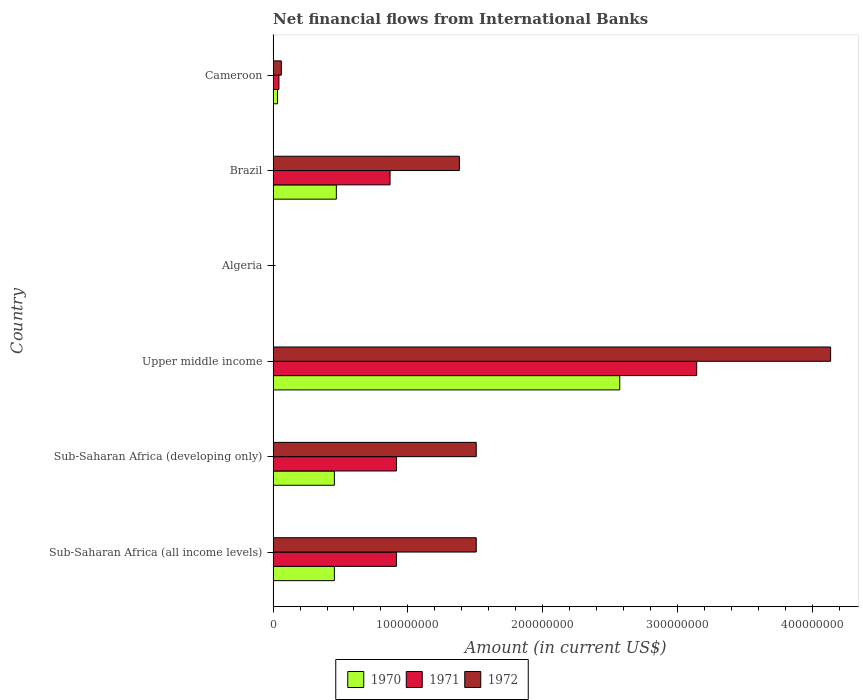Are the number of bars on each tick of the Y-axis equal?
Make the answer very short. No. How many bars are there on the 5th tick from the top?
Your answer should be very brief. 3. How many bars are there on the 3rd tick from the bottom?
Offer a very short reply. 3. What is the label of the 2nd group of bars from the top?
Offer a terse response. Brazil. What is the net financial aid flows in 1970 in Sub-Saharan Africa (all income levels)?
Offer a very short reply. 4.55e+07. Across all countries, what is the maximum net financial aid flows in 1971?
Give a very brief answer. 3.14e+08. Across all countries, what is the minimum net financial aid flows in 1971?
Offer a terse response. 0. In which country was the net financial aid flows in 1971 maximum?
Provide a succinct answer. Upper middle income. What is the total net financial aid flows in 1971 in the graph?
Ensure brevity in your answer.  5.88e+08. What is the difference between the net financial aid flows in 1972 in Brazil and that in Sub-Saharan Africa (all income levels)?
Your response must be concise. -1.25e+07. What is the difference between the net financial aid flows in 1970 in Algeria and the net financial aid flows in 1972 in Sub-Saharan Africa (developing only)?
Ensure brevity in your answer.  -1.51e+08. What is the average net financial aid flows in 1972 per country?
Your answer should be compact. 1.43e+08. What is the difference between the net financial aid flows in 1972 and net financial aid flows in 1971 in Sub-Saharan Africa (all income levels)?
Give a very brief answer. 5.92e+07. In how many countries, is the net financial aid flows in 1970 greater than 100000000 US$?
Your answer should be compact. 1. What is the ratio of the net financial aid flows in 1971 in Brazil to that in Sub-Saharan Africa (all income levels)?
Offer a very short reply. 0.95. Is the net financial aid flows in 1971 in Sub-Saharan Africa (all income levels) less than that in Sub-Saharan Africa (developing only)?
Provide a succinct answer. No. What is the difference between the highest and the second highest net financial aid flows in 1972?
Your answer should be compact. 2.63e+08. What is the difference between the highest and the lowest net financial aid flows in 1972?
Your response must be concise. 4.14e+08. In how many countries, is the net financial aid flows in 1971 greater than the average net financial aid flows in 1971 taken over all countries?
Ensure brevity in your answer.  1. Is it the case that in every country, the sum of the net financial aid flows in 1971 and net financial aid flows in 1970 is greater than the net financial aid flows in 1972?
Make the answer very short. No. How many bars are there?
Keep it short and to the point. 15. How many countries are there in the graph?
Give a very brief answer. 6. What is the difference between two consecutive major ticks on the X-axis?
Provide a short and direct response. 1.00e+08. Does the graph contain any zero values?
Make the answer very short. Yes. Does the graph contain grids?
Offer a very short reply. No. What is the title of the graph?
Give a very brief answer. Net financial flows from International Banks. What is the Amount (in current US$) of 1970 in Sub-Saharan Africa (all income levels)?
Provide a short and direct response. 4.55e+07. What is the Amount (in current US$) of 1971 in Sub-Saharan Africa (all income levels)?
Provide a short and direct response. 9.15e+07. What is the Amount (in current US$) of 1972 in Sub-Saharan Africa (all income levels)?
Ensure brevity in your answer.  1.51e+08. What is the Amount (in current US$) of 1970 in Sub-Saharan Africa (developing only)?
Ensure brevity in your answer.  4.55e+07. What is the Amount (in current US$) of 1971 in Sub-Saharan Africa (developing only)?
Provide a succinct answer. 9.15e+07. What is the Amount (in current US$) in 1972 in Sub-Saharan Africa (developing only)?
Your response must be concise. 1.51e+08. What is the Amount (in current US$) of 1970 in Upper middle income?
Ensure brevity in your answer.  2.57e+08. What is the Amount (in current US$) of 1971 in Upper middle income?
Your answer should be very brief. 3.14e+08. What is the Amount (in current US$) in 1972 in Upper middle income?
Your response must be concise. 4.14e+08. What is the Amount (in current US$) of 1971 in Algeria?
Your answer should be compact. 0. What is the Amount (in current US$) of 1972 in Algeria?
Offer a terse response. 0. What is the Amount (in current US$) in 1970 in Brazil?
Keep it short and to the point. 4.69e+07. What is the Amount (in current US$) in 1971 in Brazil?
Your answer should be very brief. 8.68e+07. What is the Amount (in current US$) of 1972 in Brazil?
Give a very brief answer. 1.38e+08. What is the Amount (in current US$) of 1970 in Cameroon?
Your response must be concise. 3.25e+06. What is the Amount (in current US$) in 1971 in Cameroon?
Your response must be concise. 4.32e+06. What is the Amount (in current US$) of 1972 in Cameroon?
Make the answer very short. 6.09e+06. Across all countries, what is the maximum Amount (in current US$) in 1970?
Your answer should be very brief. 2.57e+08. Across all countries, what is the maximum Amount (in current US$) in 1971?
Ensure brevity in your answer.  3.14e+08. Across all countries, what is the maximum Amount (in current US$) in 1972?
Offer a very short reply. 4.14e+08. Across all countries, what is the minimum Amount (in current US$) in 1970?
Provide a short and direct response. 0. Across all countries, what is the minimum Amount (in current US$) in 1971?
Your answer should be very brief. 0. What is the total Amount (in current US$) of 1970 in the graph?
Give a very brief answer. 3.98e+08. What is the total Amount (in current US$) in 1971 in the graph?
Offer a terse response. 5.88e+08. What is the total Amount (in current US$) in 1972 in the graph?
Ensure brevity in your answer.  8.59e+08. What is the difference between the Amount (in current US$) of 1970 in Sub-Saharan Africa (all income levels) and that in Sub-Saharan Africa (developing only)?
Your response must be concise. 0. What is the difference between the Amount (in current US$) of 1972 in Sub-Saharan Africa (all income levels) and that in Sub-Saharan Africa (developing only)?
Keep it short and to the point. 0. What is the difference between the Amount (in current US$) of 1970 in Sub-Saharan Africa (all income levels) and that in Upper middle income?
Give a very brief answer. -2.12e+08. What is the difference between the Amount (in current US$) in 1971 in Sub-Saharan Africa (all income levels) and that in Upper middle income?
Ensure brevity in your answer.  -2.23e+08. What is the difference between the Amount (in current US$) of 1972 in Sub-Saharan Africa (all income levels) and that in Upper middle income?
Your response must be concise. -2.63e+08. What is the difference between the Amount (in current US$) in 1970 in Sub-Saharan Africa (all income levels) and that in Brazil?
Make the answer very short. -1.45e+06. What is the difference between the Amount (in current US$) of 1971 in Sub-Saharan Africa (all income levels) and that in Brazil?
Ensure brevity in your answer.  4.75e+06. What is the difference between the Amount (in current US$) in 1972 in Sub-Saharan Africa (all income levels) and that in Brazil?
Provide a short and direct response. 1.25e+07. What is the difference between the Amount (in current US$) of 1970 in Sub-Saharan Africa (all income levels) and that in Cameroon?
Your answer should be very brief. 4.22e+07. What is the difference between the Amount (in current US$) in 1971 in Sub-Saharan Africa (all income levels) and that in Cameroon?
Provide a short and direct response. 8.72e+07. What is the difference between the Amount (in current US$) in 1972 in Sub-Saharan Africa (all income levels) and that in Cameroon?
Make the answer very short. 1.45e+08. What is the difference between the Amount (in current US$) of 1970 in Sub-Saharan Africa (developing only) and that in Upper middle income?
Your response must be concise. -2.12e+08. What is the difference between the Amount (in current US$) in 1971 in Sub-Saharan Africa (developing only) and that in Upper middle income?
Ensure brevity in your answer.  -2.23e+08. What is the difference between the Amount (in current US$) in 1972 in Sub-Saharan Africa (developing only) and that in Upper middle income?
Your answer should be very brief. -2.63e+08. What is the difference between the Amount (in current US$) in 1970 in Sub-Saharan Africa (developing only) and that in Brazil?
Make the answer very short. -1.45e+06. What is the difference between the Amount (in current US$) in 1971 in Sub-Saharan Africa (developing only) and that in Brazil?
Make the answer very short. 4.75e+06. What is the difference between the Amount (in current US$) of 1972 in Sub-Saharan Africa (developing only) and that in Brazil?
Give a very brief answer. 1.25e+07. What is the difference between the Amount (in current US$) in 1970 in Sub-Saharan Africa (developing only) and that in Cameroon?
Your response must be concise. 4.22e+07. What is the difference between the Amount (in current US$) of 1971 in Sub-Saharan Africa (developing only) and that in Cameroon?
Offer a terse response. 8.72e+07. What is the difference between the Amount (in current US$) of 1972 in Sub-Saharan Africa (developing only) and that in Cameroon?
Provide a succinct answer. 1.45e+08. What is the difference between the Amount (in current US$) in 1970 in Upper middle income and that in Brazil?
Provide a short and direct response. 2.10e+08. What is the difference between the Amount (in current US$) in 1971 in Upper middle income and that in Brazil?
Your response must be concise. 2.28e+08. What is the difference between the Amount (in current US$) of 1972 in Upper middle income and that in Brazil?
Provide a short and direct response. 2.75e+08. What is the difference between the Amount (in current US$) of 1970 in Upper middle income and that in Cameroon?
Keep it short and to the point. 2.54e+08. What is the difference between the Amount (in current US$) of 1971 in Upper middle income and that in Cameroon?
Offer a terse response. 3.10e+08. What is the difference between the Amount (in current US$) of 1972 in Upper middle income and that in Cameroon?
Offer a very short reply. 4.08e+08. What is the difference between the Amount (in current US$) of 1970 in Brazil and that in Cameroon?
Your answer should be compact. 4.37e+07. What is the difference between the Amount (in current US$) in 1971 in Brazil and that in Cameroon?
Offer a very short reply. 8.25e+07. What is the difference between the Amount (in current US$) in 1972 in Brazil and that in Cameroon?
Give a very brief answer. 1.32e+08. What is the difference between the Amount (in current US$) in 1970 in Sub-Saharan Africa (all income levels) and the Amount (in current US$) in 1971 in Sub-Saharan Africa (developing only)?
Your answer should be compact. -4.61e+07. What is the difference between the Amount (in current US$) of 1970 in Sub-Saharan Africa (all income levels) and the Amount (in current US$) of 1972 in Sub-Saharan Africa (developing only)?
Your answer should be very brief. -1.05e+08. What is the difference between the Amount (in current US$) in 1971 in Sub-Saharan Africa (all income levels) and the Amount (in current US$) in 1972 in Sub-Saharan Africa (developing only)?
Provide a succinct answer. -5.92e+07. What is the difference between the Amount (in current US$) of 1970 in Sub-Saharan Africa (all income levels) and the Amount (in current US$) of 1971 in Upper middle income?
Your response must be concise. -2.69e+08. What is the difference between the Amount (in current US$) of 1970 in Sub-Saharan Africa (all income levels) and the Amount (in current US$) of 1972 in Upper middle income?
Give a very brief answer. -3.68e+08. What is the difference between the Amount (in current US$) in 1971 in Sub-Saharan Africa (all income levels) and the Amount (in current US$) in 1972 in Upper middle income?
Provide a succinct answer. -3.22e+08. What is the difference between the Amount (in current US$) of 1970 in Sub-Saharan Africa (all income levels) and the Amount (in current US$) of 1971 in Brazil?
Your answer should be compact. -4.13e+07. What is the difference between the Amount (in current US$) in 1970 in Sub-Saharan Africa (all income levels) and the Amount (in current US$) in 1972 in Brazil?
Offer a very short reply. -9.27e+07. What is the difference between the Amount (in current US$) in 1971 in Sub-Saharan Africa (all income levels) and the Amount (in current US$) in 1972 in Brazil?
Ensure brevity in your answer.  -4.67e+07. What is the difference between the Amount (in current US$) in 1970 in Sub-Saharan Africa (all income levels) and the Amount (in current US$) in 1971 in Cameroon?
Make the answer very short. 4.11e+07. What is the difference between the Amount (in current US$) of 1970 in Sub-Saharan Africa (all income levels) and the Amount (in current US$) of 1972 in Cameroon?
Your answer should be compact. 3.94e+07. What is the difference between the Amount (in current US$) in 1971 in Sub-Saharan Africa (all income levels) and the Amount (in current US$) in 1972 in Cameroon?
Offer a terse response. 8.54e+07. What is the difference between the Amount (in current US$) of 1970 in Sub-Saharan Africa (developing only) and the Amount (in current US$) of 1971 in Upper middle income?
Make the answer very short. -2.69e+08. What is the difference between the Amount (in current US$) in 1970 in Sub-Saharan Africa (developing only) and the Amount (in current US$) in 1972 in Upper middle income?
Provide a short and direct response. -3.68e+08. What is the difference between the Amount (in current US$) in 1971 in Sub-Saharan Africa (developing only) and the Amount (in current US$) in 1972 in Upper middle income?
Keep it short and to the point. -3.22e+08. What is the difference between the Amount (in current US$) of 1970 in Sub-Saharan Africa (developing only) and the Amount (in current US$) of 1971 in Brazil?
Keep it short and to the point. -4.13e+07. What is the difference between the Amount (in current US$) of 1970 in Sub-Saharan Africa (developing only) and the Amount (in current US$) of 1972 in Brazil?
Your response must be concise. -9.27e+07. What is the difference between the Amount (in current US$) in 1971 in Sub-Saharan Africa (developing only) and the Amount (in current US$) in 1972 in Brazil?
Give a very brief answer. -4.67e+07. What is the difference between the Amount (in current US$) of 1970 in Sub-Saharan Africa (developing only) and the Amount (in current US$) of 1971 in Cameroon?
Provide a succinct answer. 4.11e+07. What is the difference between the Amount (in current US$) of 1970 in Sub-Saharan Africa (developing only) and the Amount (in current US$) of 1972 in Cameroon?
Provide a succinct answer. 3.94e+07. What is the difference between the Amount (in current US$) of 1971 in Sub-Saharan Africa (developing only) and the Amount (in current US$) of 1972 in Cameroon?
Keep it short and to the point. 8.54e+07. What is the difference between the Amount (in current US$) in 1970 in Upper middle income and the Amount (in current US$) in 1971 in Brazil?
Your response must be concise. 1.70e+08. What is the difference between the Amount (in current US$) in 1970 in Upper middle income and the Amount (in current US$) in 1972 in Brazil?
Your answer should be very brief. 1.19e+08. What is the difference between the Amount (in current US$) of 1971 in Upper middle income and the Amount (in current US$) of 1972 in Brazil?
Your answer should be very brief. 1.76e+08. What is the difference between the Amount (in current US$) in 1970 in Upper middle income and the Amount (in current US$) in 1971 in Cameroon?
Provide a short and direct response. 2.53e+08. What is the difference between the Amount (in current US$) of 1970 in Upper middle income and the Amount (in current US$) of 1972 in Cameroon?
Make the answer very short. 2.51e+08. What is the difference between the Amount (in current US$) of 1971 in Upper middle income and the Amount (in current US$) of 1972 in Cameroon?
Give a very brief answer. 3.08e+08. What is the difference between the Amount (in current US$) in 1970 in Brazil and the Amount (in current US$) in 1971 in Cameroon?
Your answer should be very brief. 4.26e+07. What is the difference between the Amount (in current US$) of 1970 in Brazil and the Amount (in current US$) of 1972 in Cameroon?
Keep it short and to the point. 4.08e+07. What is the difference between the Amount (in current US$) in 1971 in Brazil and the Amount (in current US$) in 1972 in Cameroon?
Make the answer very short. 8.07e+07. What is the average Amount (in current US$) of 1970 per country?
Ensure brevity in your answer.  6.64e+07. What is the average Amount (in current US$) of 1971 per country?
Your answer should be compact. 9.81e+07. What is the average Amount (in current US$) in 1972 per country?
Ensure brevity in your answer.  1.43e+08. What is the difference between the Amount (in current US$) in 1970 and Amount (in current US$) in 1971 in Sub-Saharan Africa (all income levels)?
Keep it short and to the point. -4.61e+07. What is the difference between the Amount (in current US$) in 1970 and Amount (in current US$) in 1972 in Sub-Saharan Africa (all income levels)?
Keep it short and to the point. -1.05e+08. What is the difference between the Amount (in current US$) of 1971 and Amount (in current US$) of 1972 in Sub-Saharan Africa (all income levels)?
Your answer should be compact. -5.92e+07. What is the difference between the Amount (in current US$) in 1970 and Amount (in current US$) in 1971 in Sub-Saharan Africa (developing only)?
Offer a terse response. -4.61e+07. What is the difference between the Amount (in current US$) in 1970 and Amount (in current US$) in 1972 in Sub-Saharan Africa (developing only)?
Your response must be concise. -1.05e+08. What is the difference between the Amount (in current US$) in 1971 and Amount (in current US$) in 1972 in Sub-Saharan Africa (developing only)?
Ensure brevity in your answer.  -5.92e+07. What is the difference between the Amount (in current US$) of 1970 and Amount (in current US$) of 1971 in Upper middle income?
Your answer should be compact. -5.71e+07. What is the difference between the Amount (in current US$) of 1970 and Amount (in current US$) of 1972 in Upper middle income?
Ensure brevity in your answer.  -1.56e+08. What is the difference between the Amount (in current US$) of 1971 and Amount (in current US$) of 1972 in Upper middle income?
Ensure brevity in your answer.  -9.94e+07. What is the difference between the Amount (in current US$) in 1970 and Amount (in current US$) in 1971 in Brazil?
Provide a short and direct response. -3.99e+07. What is the difference between the Amount (in current US$) of 1970 and Amount (in current US$) of 1972 in Brazil?
Your answer should be very brief. -9.13e+07. What is the difference between the Amount (in current US$) in 1971 and Amount (in current US$) in 1972 in Brazil?
Ensure brevity in your answer.  -5.14e+07. What is the difference between the Amount (in current US$) in 1970 and Amount (in current US$) in 1971 in Cameroon?
Your response must be concise. -1.07e+06. What is the difference between the Amount (in current US$) in 1970 and Amount (in current US$) in 1972 in Cameroon?
Ensure brevity in your answer.  -2.84e+06. What is the difference between the Amount (in current US$) of 1971 and Amount (in current US$) of 1972 in Cameroon?
Give a very brief answer. -1.77e+06. What is the ratio of the Amount (in current US$) in 1970 in Sub-Saharan Africa (all income levels) to that in Sub-Saharan Africa (developing only)?
Provide a succinct answer. 1. What is the ratio of the Amount (in current US$) in 1971 in Sub-Saharan Africa (all income levels) to that in Sub-Saharan Africa (developing only)?
Provide a short and direct response. 1. What is the ratio of the Amount (in current US$) of 1972 in Sub-Saharan Africa (all income levels) to that in Sub-Saharan Africa (developing only)?
Provide a succinct answer. 1. What is the ratio of the Amount (in current US$) of 1970 in Sub-Saharan Africa (all income levels) to that in Upper middle income?
Offer a terse response. 0.18. What is the ratio of the Amount (in current US$) in 1971 in Sub-Saharan Africa (all income levels) to that in Upper middle income?
Keep it short and to the point. 0.29. What is the ratio of the Amount (in current US$) of 1972 in Sub-Saharan Africa (all income levels) to that in Upper middle income?
Your response must be concise. 0.36. What is the ratio of the Amount (in current US$) of 1970 in Sub-Saharan Africa (all income levels) to that in Brazil?
Offer a very short reply. 0.97. What is the ratio of the Amount (in current US$) of 1971 in Sub-Saharan Africa (all income levels) to that in Brazil?
Offer a very short reply. 1.05. What is the ratio of the Amount (in current US$) of 1972 in Sub-Saharan Africa (all income levels) to that in Brazil?
Offer a terse response. 1.09. What is the ratio of the Amount (in current US$) in 1970 in Sub-Saharan Africa (all income levels) to that in Cameroon?
Offer a very short reply. 13.99. What is the ratio of the Amount (in current US$) of 1971 in Sub-Saharan Africa (all income levels) to that in Cameroon?
Your response must be concise. 21.2. What is the ratio of the Amount (in current US$) of 1972 in Sub-Saharan Africa (all income levels) to that in Cameroon?
Your response must be concise. 24.76. What is the ratio of the Amount (in current US$) in 1970 in Sub-Saharan Africa (developing only) to that in Upper middle income?
Your answer should be compact. 0.18. What is the ratio of the Amount (in current US$) of 1971 in Sub-Saharan Africa (developing only) to that in Upper middle income?
Ensure brevity in your answer.  0.29. What is the ratio of the Amount (in current US$) of 1972 in Sub-Saharan Africa (developing only) to that in Upper middle income?
Your answer should be very brief. 0.36. What is the ratio of the Amount (in current US$) in 1970 in Sub-Saharan Africa (developing only) to that in Brazil?
Your answer should be very brief. 0.97. What is the ratio of the Amount (in current US$) of 1971 in Sub-Saharan Africa (developing only) to that in Brazil?
Keep it short and to the point. 1.05. What is the ratio of the Amount (in current US$) in 1972 in Sub-Saharan Africa (developing only) to that in Brazil?
Offer a terse response. 1.09. What is the ratio of the Amount (in current US$) in 1970 in Sub-Saharan Africa (developing only) to that in Cameroon?
Make the answer very short. 13.99. What is the ratio of the Amount (in current US$) in 1971 in Sub-Saharan Africa (developing only) to that in Cameroon?
Your answer should be very brief. 21.2. What is the ratio of the Amount (in current US$) of 1972 in Sub-Saharan Africa (developing only) to that in Cameroon?
Ensure brevity in your answer.  24.76. What is the ratio of the Amount (in current US$) in 1970 in Upper middle income to that in Brazil?
Your answer should be very brief. 5.48. What is the ratio of the Amount (in current US$) in 1971 in Upper middle income to that in Brazil?
Offer a very short reply. 3.62. What is the ratio of the Amount (in current US$) of 1972 in Upper middle income to that in Brazil?
Keep it short and to the point. 2.99. What is the ratio of the Amount (in current US$) of 1970 in Upper middle income to that in Cameroon?
Offer a terse response. 79.15. What is the ratio of the Amount (in current US$) in 1971 in Upper middle income to that in Cameroon?
Offer a terse response. 72.81. What is the ratio of the Amount (in current US$) in 1972 in Upper middle income to that in Cameroon?
Offer a very short reply. 67.96. What is the ratio of the Amount (in current US$) in 1970 in Brazil to that in Cameroon?
Your answer should be compact. 14.44. What is the ratio of the Amount (in current US$) of 1971 in Brazil to that in Cameroon?
Your response must be concise. 20.1. What is the ratio of the Amount (in current US$) in 1972 in Brazil to that in Cameroon?
Your response must be concise. 22.7. What is the difference between the highest and the second highest Amount (in current US$) in 1970?
Keep it short and to the point. 2.10e+08. What is the difference between the highest and the second highest Amount (in current US$) of 1971?
Offer a very short reply. 2.23e+08. What is the difference between the highest and the second highest Amount (in current US$) in 1972?
Keep it short and to the point. 2.63e+08. What is the difference between the highest and the lowest Amount (in current US$) of 1970?
Provide a short and direct response. 2.57e+08. What is the difference between the highest and the lowest Amount (in current US$) in 1971?
Give a very brief answer. 3.14e+08. What is the difference between the highest and the lowest Amount (in current US$) in 1972?
Your answer should be compact. 4.14e+08. 